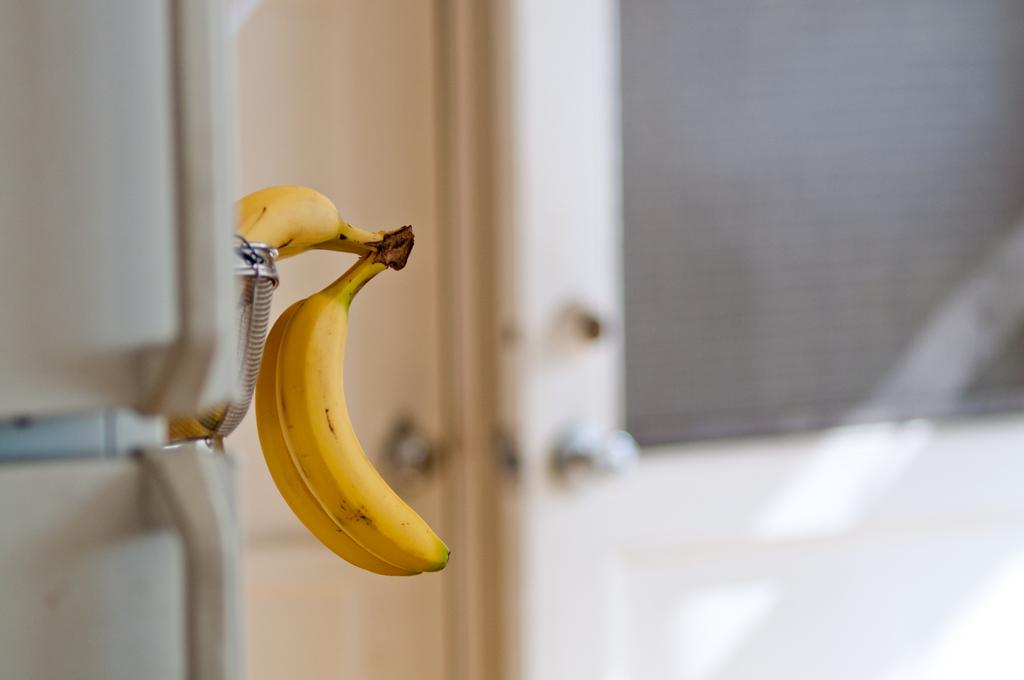What fruit is present in the image? There are two bananas in the image. How are the bananas positioned in the image? The bananas are kept on a stand. Can you describe the background of the image? The background of the image is slightly blurry. What type of sack is being advertised in the image? There is no sack being advertised in the image; it features two bananas on a stand. What reason might someone have for placing the bananas on the stand in the image? The image does not provide information about the reason for placing the bananas on the stand. 